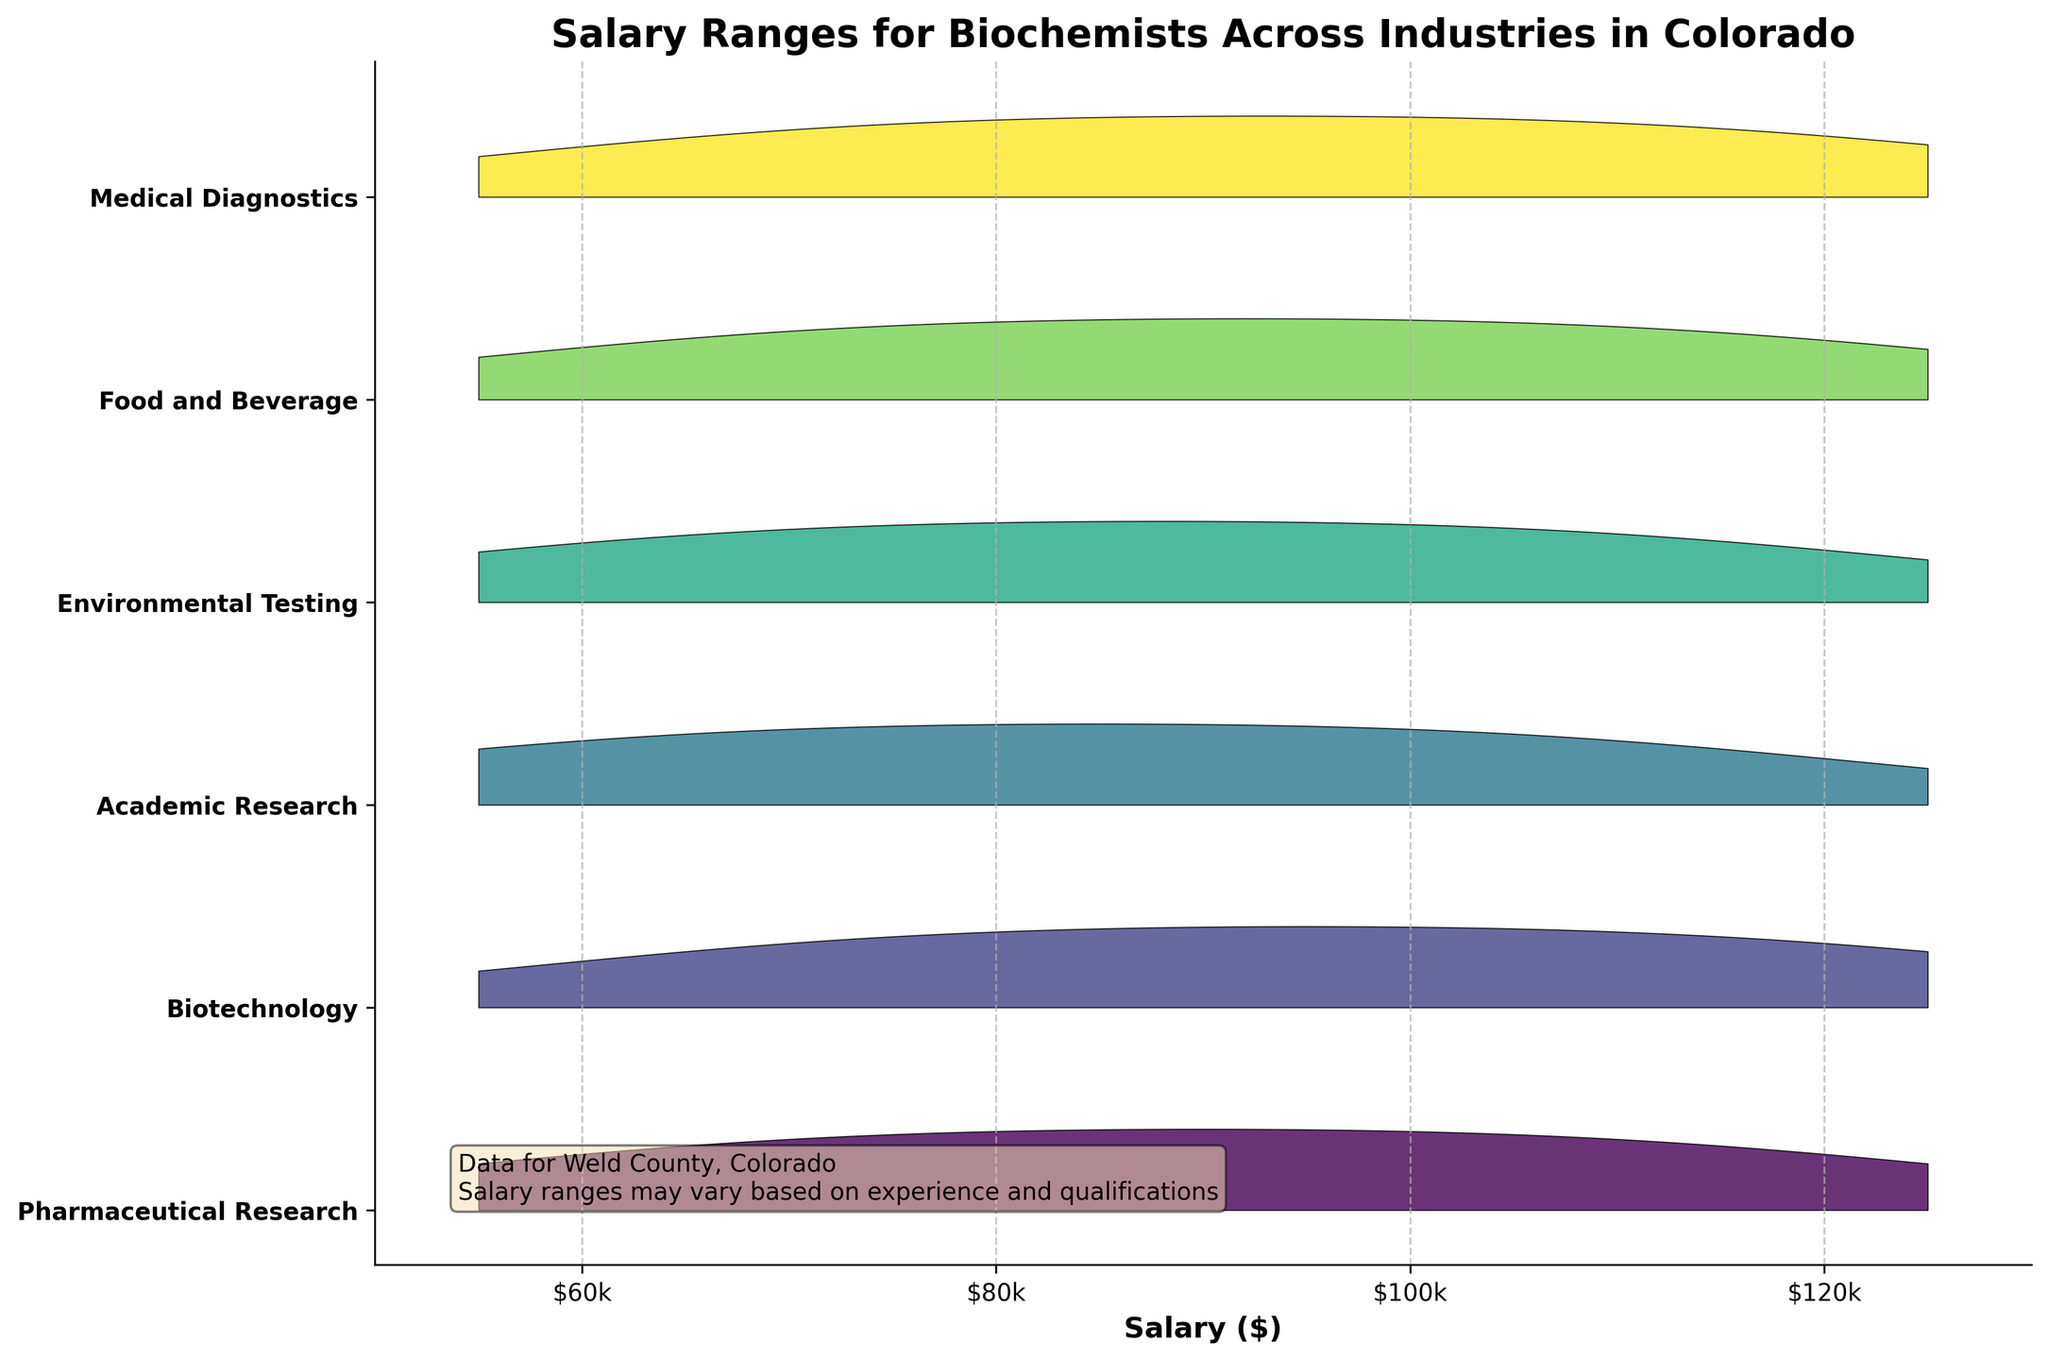What is the title of the plot? The title of the plot is clearly displayed at the top of the figure.
Answer: Salary Ranges for Biochemists Across Industries in Colorado Which industry has the highest salary range? By observing the range along the x-axis for each industry, we can see the maximum salary value.
Answer: Medical Diagnostics What is the range of salaries for Academic Research biochemists? Look at the area covered in the ridgeline plot for Academic Research along the x-axis. The range can be read from the minimum to the maximum salary values visible.
Answer: $55,000 to $115,000 Which industry seems to have the narrowest salary distribution? By comparing the width of the ridgelines along the x-axis, the industry with the smallest range of salary values can be found.
Answer: Environmental Testing How many salary tick marks are there on the x-axis, and what are their labels? Count the number of tick marks on the x-axis and read their labels.
Answer: Four tick marks labeled $60k, $80k, $100k, $120k Which industries have a salary peak around $90,000? Observe the bumps or peaks in the plot that align with the $90,000 mark on the x-axis. Multiple industries might have peaks near this value.
Answer: Pharmaceutical Research, Food and Beverage, Medical Diagnostics, Environmental Testing What is the primary color palette used in the plot? Look at the colors used for different industries in the figure; the palette typically has a name.
Answer: Viridis How is the height of each ridgeline scaled? The explanation box in the plot provides a clue about the scaling of the height. It says the height is scaled but doesn't state specific numeric data, suggesting intuitive scaling as per common practice.
Answer: Scaled proportionally based on the density of salary values Which industry has a peak in the $100,000 salary range? Identify the industry ridgeline that reaches its maximum height around the $100,000 mark on the x-axis.
Answer: Academic Research Is there an industry that does not reach a $120,000 salary? Scan each ridgeline to see if all of them have parts extending to or beyond the $120,000 mark on the x-axis.
Answer: Academic Research 